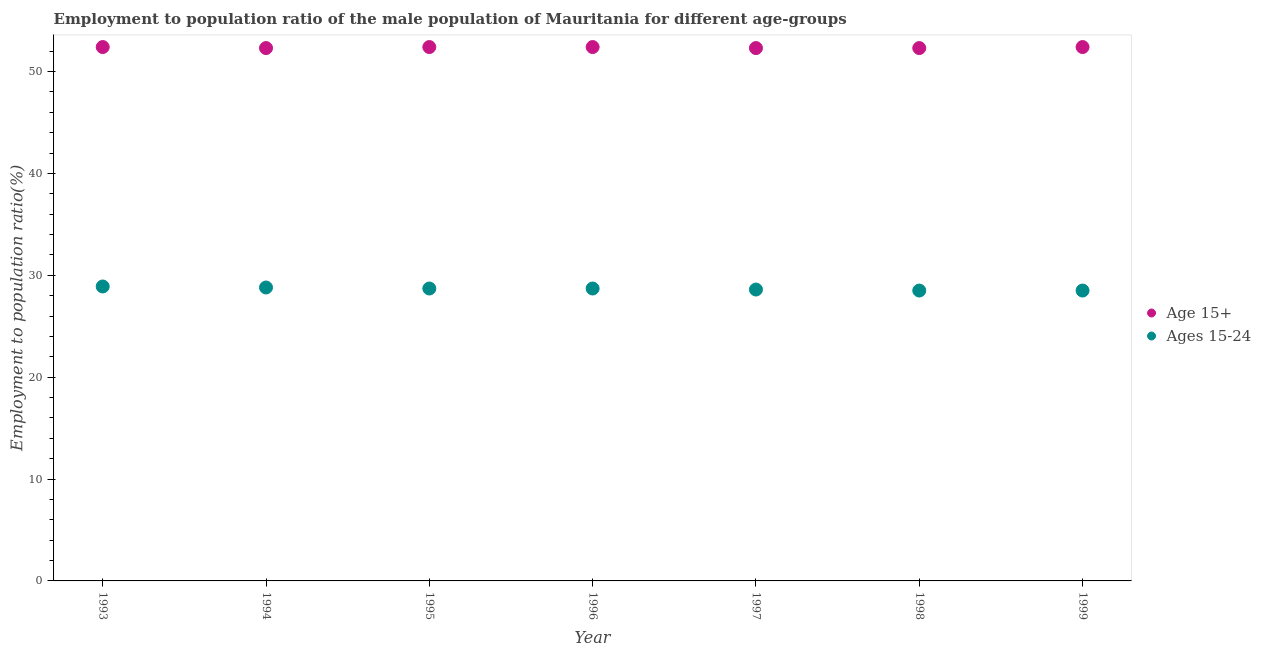How many different coloured dotlines are there?
Give a very brief answer. 2. Across all years, what is the maximum employment to population ratio(age 15-24)?
Keep it short and to the point. 28.9. Across all years, what is the minimum employment to population ratio(age 15+)?
Offer a very short reply. 52.3. In which year was the employment to population ratio(age 15-24) maximum?
Give a very brief answer. 1993. In which year was the employment to population ratio(age 15+) minimum?
Your response must be concise. 1994. What is the total employment to population ratio(age 15+) in the graph?
Your response must be concise. 366.5. What is the difference between the employment to population ratio(age 15-24) in 1994 and that in 1996?
Keep it short and to the point. 0.1. What is the difference between the employment to population ratio(age 15+) in 1994 and the employment to population ratio(age 15-24) in 1999?
Offer a terse response. 23.8. What is the average employment to population ratio(age 15-24) per year?
Your response must be concise. 28.67. In the year 1993, what is the difference between the employment to population ratio(age 15-24) and employment to population ratio(age 15+)?
Keep it short and to the point. -23.5. What is the ratio of the employment to population ratio(age 15+) in 1994 to that in 1997?
Keep it short and to the point. 1. Is the employment to population ratio(age 15-24) in 1997 less than that in 1998?
Offer a terse response. No. What is the difference between the highest and the second highest employment to population ratio(age 15+)?
Your response must be concise. 0. What is the difference between the highest and the lowest employment to population ratio(age 15-24)?
Your answer should be compact. 0.4. In how many years, is the employment to population ratio(age 15-24) greater than the average employment to population ratio(age 15-24) taken over all years?
Provide a short and direct response. 4. Is the employment to population ratio(age 15-24) strictly greater than the employment to population ratio(age 15+) over the years?
Offer a terse response. No. What is the difference between two consecutive major ticks on the Y-axis?
Your answer should be compact. 10. Does the graph contain any zero values?
Make the answer very short. No. Does the graph contain grids?
Provide a succinct answer. No. Where does the legend appear in the graph?
Provide a succinct answer. Center right. How are the legend labels stacked?
Ensure brevity in your answer.  Vertical. What is the title of the graph?
Ensure brevity in your answer.  Employment to population ratio of the male population of Mauritania for different age-groups. What is the label or title of the Y-axis?
Provide a succinct answer. Employment to population ratio(%). What is the Employment to population ratio(%) of Age 15+ in 1993?
Your answer should be very brief. 52.4. What is the Employment to population ratio(%) of Ages 15-24 in 1993?
Offer a terse response. 28.9. What is the Employment to population ratio(%) of Age 15+ in 1994?
Provide a short and direct response. 52.3. What is the Employment to population ratio(%) in Ages 15-24 in 1994?
Provide a short and direct response. 28.8. What is the Employment to population ratio(%) in Age 15+ in 1995?
Offer a very short reply. 52.4. What is the Employment to population ratio(%) in Ages 15-24 in 1995?
Offer a terse response. 28.7. What is the Employment to population ratio(%) in Age 15+ in 1996?
Your answer should be compact. 52.4. What is the Employment to population ratio(%) of Ages 15-24 in 1996?
Your answer should be compact. 28.7. What is the Employment to population ratio(%) of Age 15+ in 1997?
Offer a very short reply. 52.3. What is the Employment to population ratio(%) in Ages 15-24 in 1997?
Offer a very short reply. 28.6. What is the Employment to population ratio(%) of Age 15+ in 1998?
Keep it short and to the point. 52.3. What is the Employment to population ratio(%) of Ages 15-24 in 1998?
Your response must be concise. 28.5. What is the Employment to population ratio(%) in Age 15+ in 1999?
Ensure brevity in your answer.  52.4. What is the Employment to population ratio(%) of Ages 15-24 in 1999?
Your answer should be compact. 28.5. Across all years, what is the maximum Employment to population ratio(%) of Age 15+?
Your answer should be compact. 52.4. Across all years, what is the maximum Employment to population ratio(%) in Ages 15-24?
Offer a terse response. 28.9. Across all years, what is the minimum Employment to population ratio(%) in Age 15+?
Offer a terse response. 52.3. Across all years, what is the minimum Employment to population ratio(%) in Ages 15-24?
Your answer should be compact. 28.5. What is the total Employment to population ratio(%) of Age 15+ in the graph?
Keep it short and to the point. 366.5. What is the total Employment to population ratio(%) of Ages 15-24 in the graph?
Your answer should be compact. 200.7. What is the difference between the Employment to population ratio(%) in Ages 15-24 in 1993 and that in 1994?
Make the answer very short. 0.1. What is the difference between the Employment to population ratio(%) of Ages 15-24 in 1993 and that in 1996?
Make the answer very short. 0.2. What is the difference between the Employment to population ratio(%) of Age 15+ in 1993 and that in 1997?
Provide a short and direct response. 0.1. What is the difference between the Employment to population ratio(%) in Age 15+ in 1993 and that in 1998?
Your answer should be very brief. 0.1. What is the difference between the Employment to population ratio(%) of Ages 15-24 in 1993 and that in 1999?
Keep it short and to the point. 0.4. What is the difference between the Employment to population ratio(%) of Ages 15-24 in 1994 and that in 1995?
Provide a succinct answer. 0.1. What is the difference between the Employment to population ratio(%) in Age 15+ in 1994 and that in 1996?
Ensure brevity in your answer.  -0.1. What is the difference between the Employment to population ratio(%) in Age 15+ in 1994 and that in 1998?
Keep it short and to the point. 0. What is the difference between the Employment to population ratio(%) in Age 15+ in 1994 and that in 1999?
Your answer should be very brief. -0.1. What is the difference between the Employment to population ratio(%) of Age 15+ in 1995 and that in 1996?
Your response must be concise. 0. What is the difference between the Employment to population ratio(%) of Ages 15-24 in 1995 and that in 1998?
Offer a very short reply. 0.2. What is the difference between the Employment to population ratio(%) of Age 15+ in 1995 and that in 1999?
Make the answer very short. 0. What is the difference between the Employment to population ratio(%) of Age 15+ in 1996 and that in 1998?
Give a very brief answer. 0.1. What is the difference between the Employment to population ratio(%) of Age 15+ in 1996 and that in 1999?
Your answer should be compact. 0. What is the difference between the Employment to population ratio(%) of Ages 15-24 in 1996 and that in 1999?
Ensure brevity in your answer.  0.2. What is the difference between the Employment to population ratio(%) of Age 15+ in 1998 and that in 1999?
Your response must be concise. -0.1. What is the difference between the Employment to population ratio(%) of Age 15+ in 1993 and the Employment to population ratio(%) of Ages 15-24 in 1994?
Offer a very short reply. 23.6. What is the difference between the Employment to population ratio(%) of Age 15+ in 1993 and the Employment to population ratio(%) of Ages 15-24 in 1995?
Keep it short and to the point. 23.7. What is the difference between the Employment to population ratio(%) of Age 15+ in 1993 and the Employment to population ratio(%) of Ages 15-24 in 1996?
Keep it short and to the point. 23.7. What is the difference between the Employment to population ratio(%) of Age 15+ in 1993 and the Employment to population ratio(%) of Ages 15-24 in 1997?
Make the answer very short. 23.8. What is the difference between the Employment to population ratio(%) in Age 15+ in 1993 and the Employment to population ratio(%) in Ages 15-24 in 1998?
Provide a succinct answer. 23.9. What is the difference between the Employment to population ratio(%) of Age 15+ in 1993 and the Employment to population ratio(%) of Ages 15-24 in 1999?
Offer a very short reply. 23.9. What is the difference between the Employment to population ratio(%) in Age 15+ in 1994 and the Employment to population ratio(%) in Ages 15-24 in 1995?
Offer a very short reply. 23.6. What is the difference between the Employment to population ratio(%) of Age 15+ in 1994 and the Employment to population ratio(%) of Ages 15-24 in 1996?
Offer a terse response. 23.6. What is the difference between the Employment to population ratio(%) of Age 15+ in 1994 and the Employment to population ratio(%) of Ages 15-24 in 1997?
Give a very brief answer. 23.7. What is the difference between the Employment to population ratio(%) in Age 15+ in 1994 and the Employment to population ratio(%) in Ages 15-24 in 1998?
Provide a short and direct response. 23.8. What is the difference between the Employment to population ratio(%) in Age 15+ in 1994 and the Employment to population ratio(%) in Ages 15-24 in 1999?
Your answer should be very brief. 23.8. What is the difference between the Employment to population ratio(%) in Age 15+ in 1995 and the Employment to population ratio(%) in Ages 15-24 in 1996?
Offer a terse response. 23.7. What is the difference between the Employment to population ratio(%) of Age 15+ in 1995 and the Employment to population ratio(%) of Ages 15-24 in 1997?
Your response must be concise. 23.8. What is the difference between the Employment to population ratio(%) in Age 15+ in 1995 and the Employment to population ratio(%) in Ages 15-24 in 1998?
Make the answer very short. 23.9. What is the difference between the Employment to population ratio(%) in Age 15+ in 1995 and the Employment to population ratio(%) in Ages 15-24 in 1999?
Your answer should be very brief. 23.9. What is the difference between the Employment to population ratio(%) of Age 15+ in 1996 and the Employment to population ratio(%) of Ages 15-24 in 1997?
Provide a short and direct response. 23.8. What is the difference between the Employment to population ratio(%) in Age 15+ in 1996 and the Employment to population ratio(%) in Ages 15-24 in 1998?
Your answer should be compact. 23.9. What is the difference between the Employment to population ratio(%) of Age 15+ in 1996 and the Employment to population ratio(%) of Ages 15-24 in 1999?
Offer a very short reply. 23.9. What is the difference between the Employment to population ratio(%) in Age 15+ in 1997 and the Employment to population ratio(%) in Ages 15-24 in 1998?
Offer a very short reply. 23.8. What is the difference between the Employment to population ratio(%) in Age 15+ in 1997 and the Employment to population ratio(%) in Ages 15-24 in 1999?
Your response must be concise. 23.8. What is the difference between the Employment to population ratio(%) of Age 15+ in 1998 and the Employment to population ratio(%) of Ages 15-24 in 1999?
Give a very brief answer. 23.8. What is the average Employment to population ratio(%) in Age 15+ per year?
Make the answer very short. 52.36. What is the average Employment to population ratio(%) in Ages 15-24 per year?
Your answer should be compact. 28.67. In the year 1995, what is the difference between the Employment to population ratio(%) in Age 15+ and Employment to population ratio(%) in Ages 15-24?
Provide a short and direct response. 23.7. In the year 1996, what is the difference between the Employment to population ratio(%) of Age 15+ and Employment to population ratio(%) of Ages 15-24?
Provide a succinct answer. 23.7. In the year 1997, what is the difference between the Employment to population ratio(%) in Age 15+ and Employment to population ratio(%) in Ages 15-24?
Offer a terse response. 23.7. In the year 1998, what is the difference between the Employment to population ratio(%) of Age 15+ and Employment to population ratio(%) of Ages 15-24?
Provide a succinct answer. 23.8. In the year 1999, what is the difference between the Employment to population ratio(%) of Age 15+ and Employment to population ratio(%) of Ages 15-24?
Your answer should be very brief. 23.9. What is the ratio of the Employment to population ratio(%) of Age 15+ in 1993 to that in 1994?
Provide a short and direct response. 1. What is the ratio of the Employment to population ratio(%) in Ages 15-24 in 1993 to that in 1994?
Offer a very short reply. 1. What is the ratio of the Employment to population ratio(%) in Age 15+ in 1993 to that in 1995?
Provide a succinct answer. 1. What is the ratio of the Employment to population ratio(%) in Ages 15-24 in 1993 to that in 1995?
Give a very brief answer. 1.01. What is the ratio of the Employment to population ratio(%) in Ages 15-24 in 1993 to that in 1996?
Ensure brevity in your answer.  1.01. What is the ratio of the Employment to population ratio(%) of Age 15+ in 1993 to that in 1997?
Keep it short and to the point. 1. What is the ratio of the Employment to population ratio(%) of Ages 15-24 in 1993 to that in 1997?
Offer a terse response. 1.01. What is the ratio of the Employment to population ratio(%) of Age 15+ in 1993 to that in 1998?
Ensure brevity in your answer.  1. What is the ratio of the Employment to population ratio(%) of Ages 15-24 in 1994 to that in 1995?
Keep it short and to the point. 1. What is the ratio of the Employment to population ratio(%) of Ages 15-24 in 1994 to that in 1996?
Your answer should be compact. 1. What is the ratio of the Employment to population ratio(%) in Age 15+ in 1994 to that in 1997?
Your answer should be compact. 1. What is the ratio of the Employment to population ratio(%) in Ages 15-24 in 1994 to that in 1997?
Keep it short and to the point. 1.01. What is the ratio of the Employment to population ratio(%) of Age 15+ in 1994 to that in 1998?
Offer a terse response. 1. What is the ratio of the Employment to population ratio(%) in Ages 15-24 in 1994 to that in 1998?
Give a very brief answer. 1.01. What is the ratio of the Employment to population ratio(%) of Ages 15-24 in 1994 to that in 1999?
Your response must be concise. 1.01. What is the ratio of the Employment to population ratio(%) in Age 15+ in 1995 to that in 1997?
Make the answer very short. 1. What is the ratio of the Employment to population ratio(%) in Age 15+ in 1995 to that in 1998?
Ensure brevity in your answer.  1. What is the ratio of the Employment to population ratio(%) of Age 15+ in 1995 to that in 1999?
Offer a very short reply. 1. What is the ratio of the Employment to population ratio(%) of Age 15+ in 1996 to that in 1997?
Offer a terse response. 1. What is the ratio of the Employment to population ratio(%) in Age 15+ in 1996 to that in 1998?
Make the answer very short. 1. What is the ratio of the Employment to population ratio(%) of Age 15+ in 1996 to that in 1999?
Provide a short and direct response. 1. What is the ratio of the Employment to population ratio(%) of Age 15+ in 1997 to that in 1998?
Keep it short and to the point. 1. 